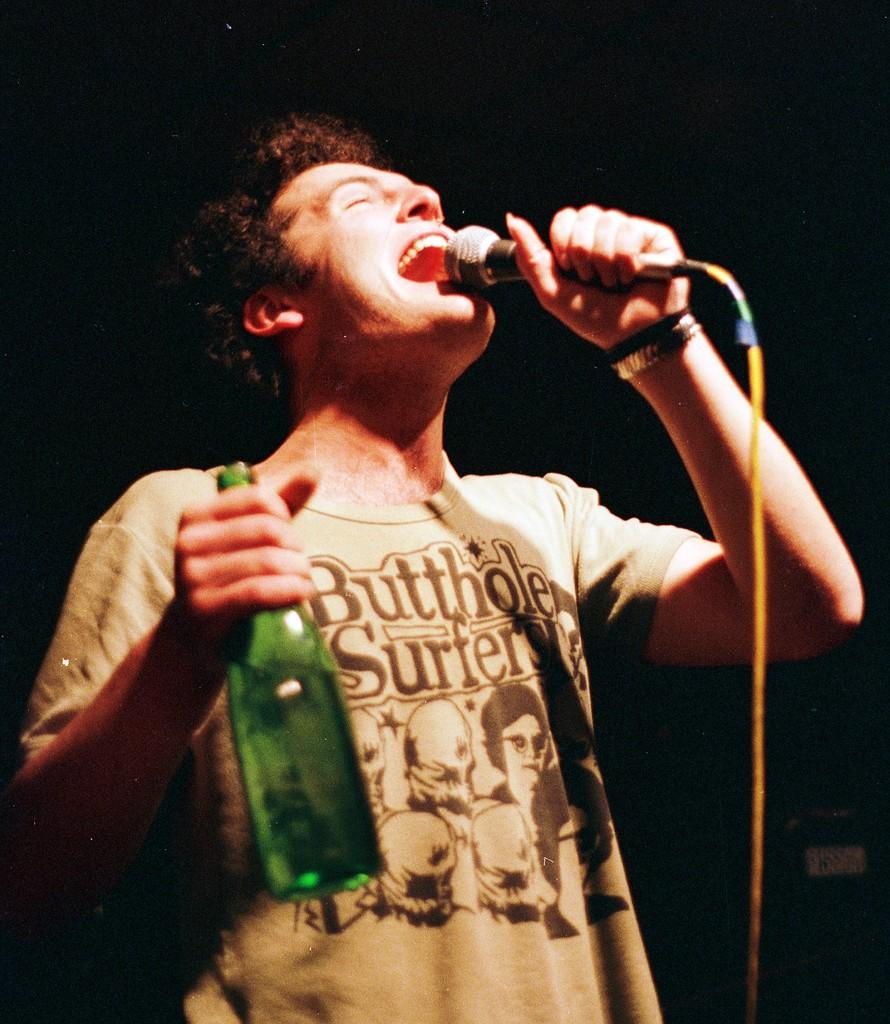Who is the main subject in the image? There is a man in the center of the image. What is the man doing in the image? The man is singing a song. What object is the man holding in the image? The man is holding a bottle. What device is the man using to amplify his voice? The man has a microphone in his hand. What type of soda is the man drinking from the bottle in the image? There is no indication in the image that the man is drinking soda from the bottle; it is not mentioned in the provided facts. 